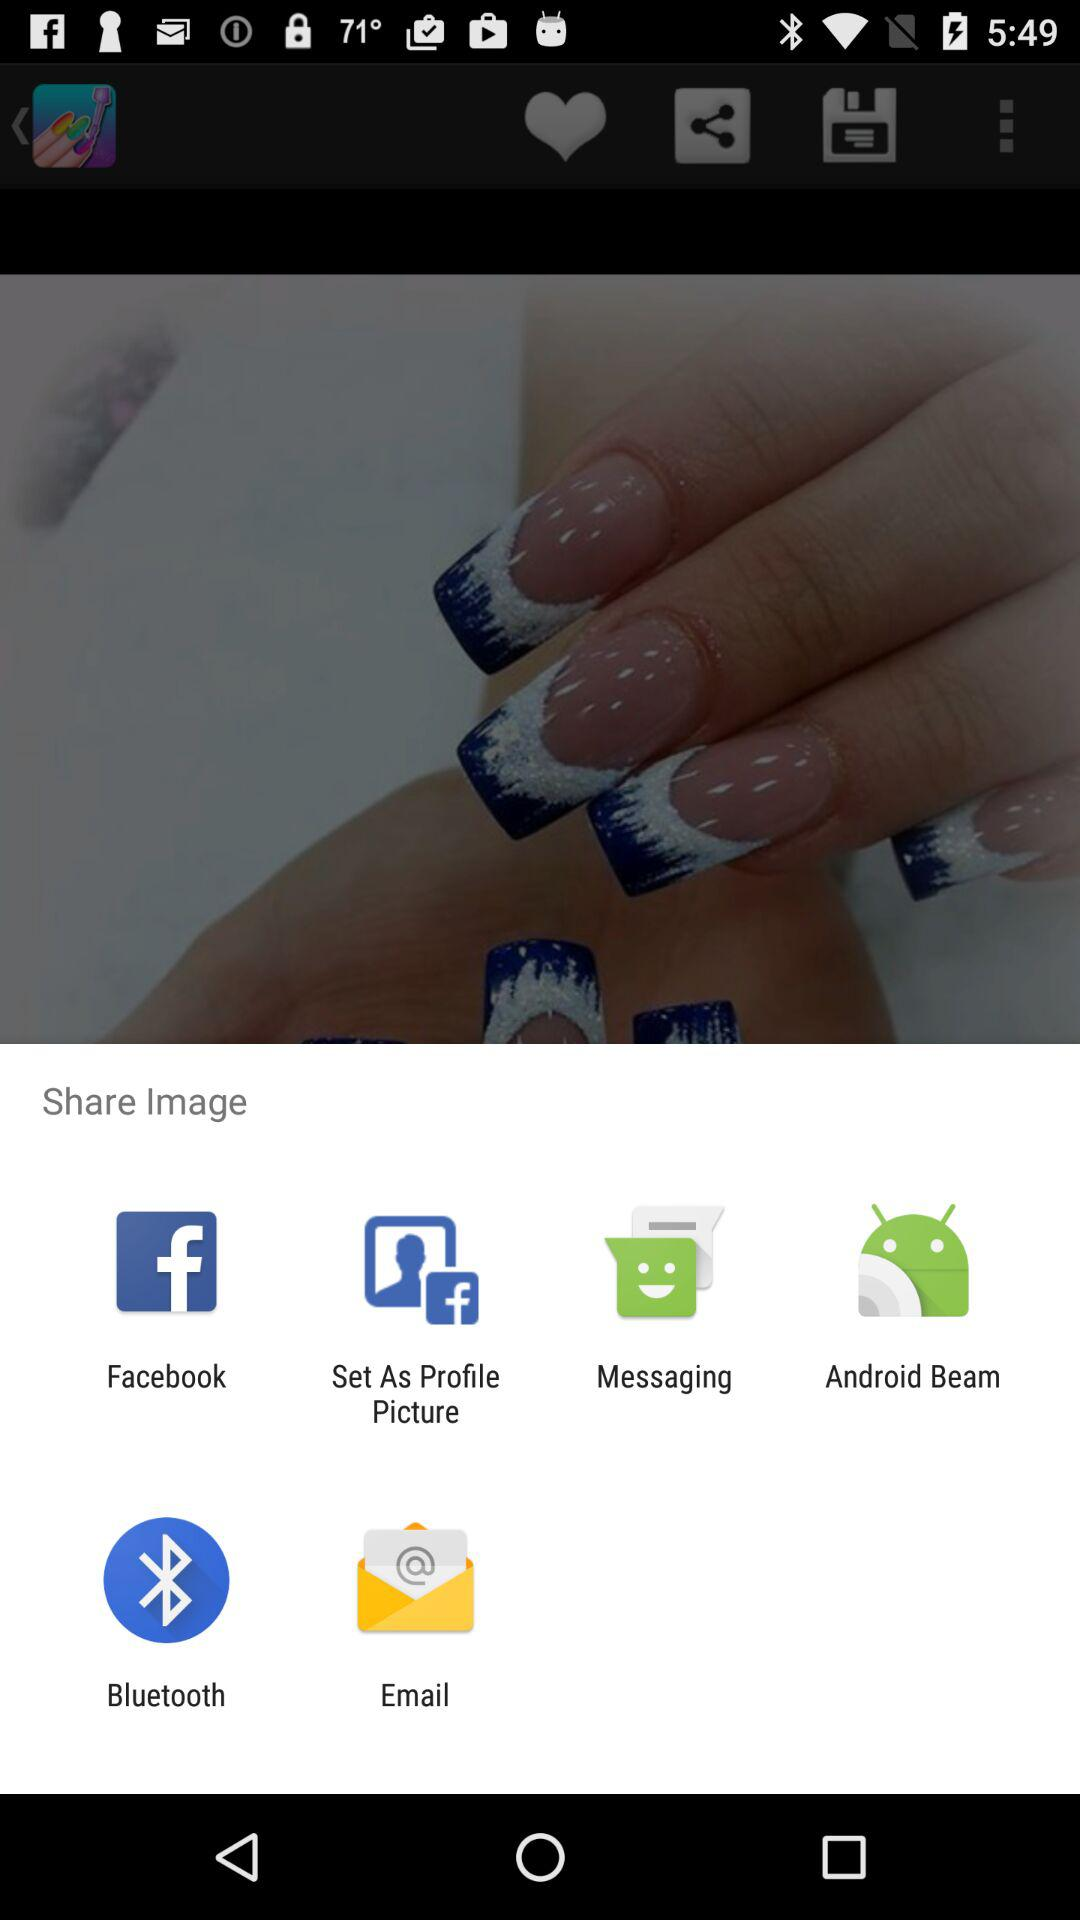Through which application can the image be shared? The image can be shared through "Facebook", "Set As Profile Picture", "Messaging", "Android Beam", "Bluetooth" and "Email". 